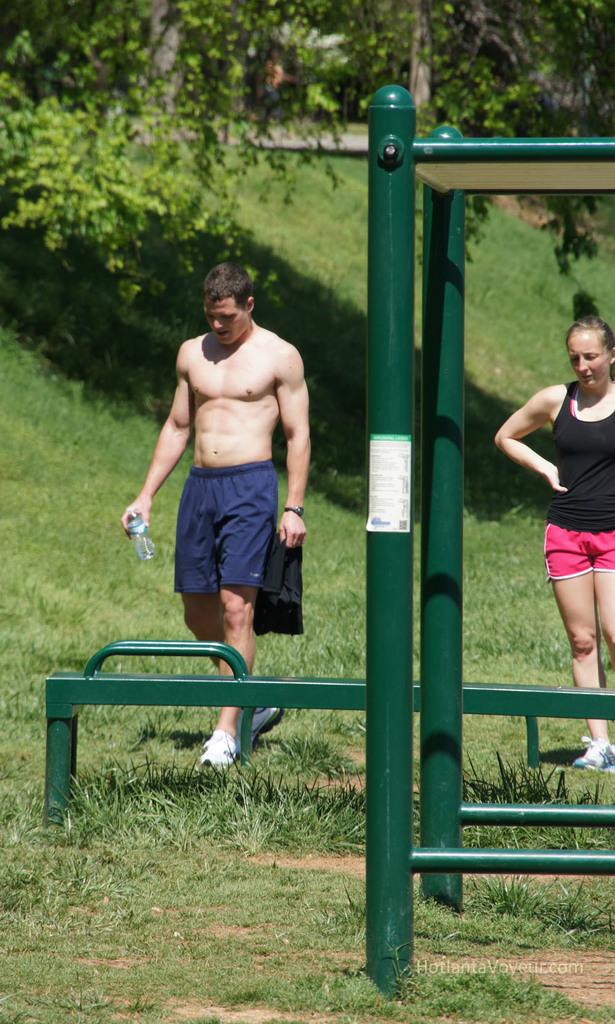What color are the rods in the image? The rods in the image are green. What can be seen in the background of the image? There is a man, a lady, and trees in the background of the image. What is the ground made of in the image? The ground in the image is covered with grass. What type of animals can be seen in the zoo in the image? There is no zoo present in the image; it features green color rods and a background with a man, a lady, and trees. 